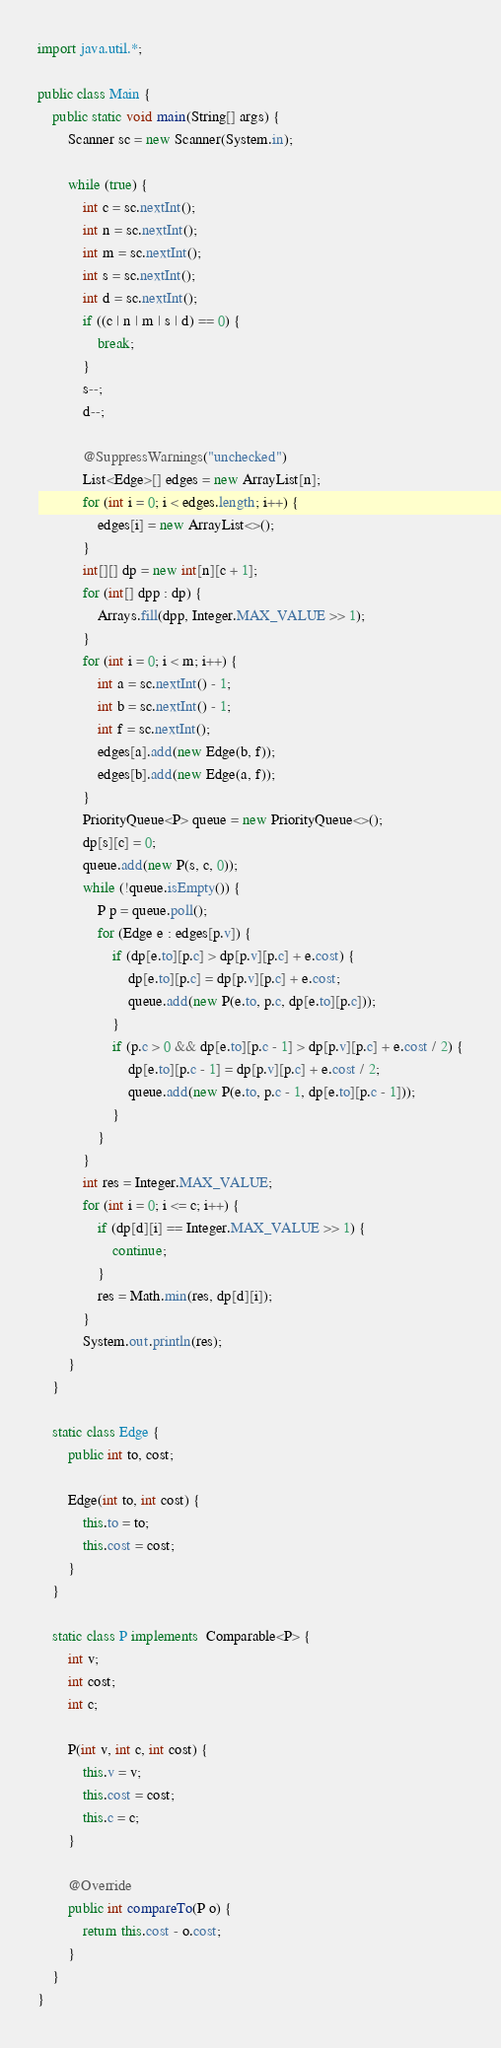<code> <loc_0><loc_0><loc_500><loc_500><_Java_>import java.util.*;

public class Main {
    public static void main(String[] args) {
        Scanner sc = new Scanner(System.in);

        while (true) {
            int c = sc.nextInt();
            int n = sc.nextInt();
            int m = sc.nextInt();
            int s = sc.nextInt();
            int d = sc.nextInt();
            if ((c | n | m | s | d) == 0) {
                break;
            }
            s--;
            d--;

            @SuppressWarnings("unchecked")
            List<Edge>[] edges = new ArrayList[n];
            for (int i = 0; i < edges.length; i++) {
                edges[i] = new ArrayList<>();
            }
            int[][] dp = new int[n][c + 1];
            for (int[] dpp : dp) {
                Arrays.fill(dpp, Integer.MAX_VALUE >> 1);
            }
            for (int i = 0; i < m; i++) {
                int a = sc.nextInt() - 1;
                int b = sc.nextInt() - 1;
                int f = sc.nextInt();
                edges[a].add(new Edge(b, f));
                edges[b].add(new Edge(a, f));
            }
            PriorityQueue<P> queue = new PriorityQueue<>();
            dp[s][c] = 0;
            queue.add(new P(s, c, 0));
            while (!queue.isEmpty()) {
                P p = queue.poll();
                for (Edge e : edges[p.v]) {
                    if (dp[e.to][p.c] > dp[p.v][p.c] + e.cost) {
                        dp[e.to][p.c] = dp[p.v][p.c] + e.cost;
                        queue.add(new P(e.to, p.c, dp[e.to][p.c]));
                    }
                    if (p.c > 0 && dp[e.to][p.c - 1] > dp[p.v][p.c] + e.cost / 2) {
                        dp[e.to][p.c - 1] = dp[p.v][p.c] + e.cost / 2;
                        queue.add(new P(e.to, p.c - 1, dp[e.to][p.c - 1]));
                    }
                }
            }
            int res = Integer.MAX_VALUE;
            for (int i = 0; i <= c; i++) {
                if (dp[d][i] == Integer.MAX_VALUE >> 1) {
                    continue;
                }
                res = Math.min(res, dp[d][i]);
            }
            System.out.println(res);
        }
    }

    static class Edge {
        public int to, cost;

        Edge(int to, int cost) {
            this.to = to;
            this.cost = cost;
        }
    }

    static class P implements  Comparable<P> {
        int v;
        int cost;
        int c;

        P(int v, int c, int cost) {
            this.v = v;
            this.cost = cost;
            this.c = c;
        }

        @Override
        public int compareTo(P o) {
            return this.cost - o.cost;
        }
    }
}</code> 